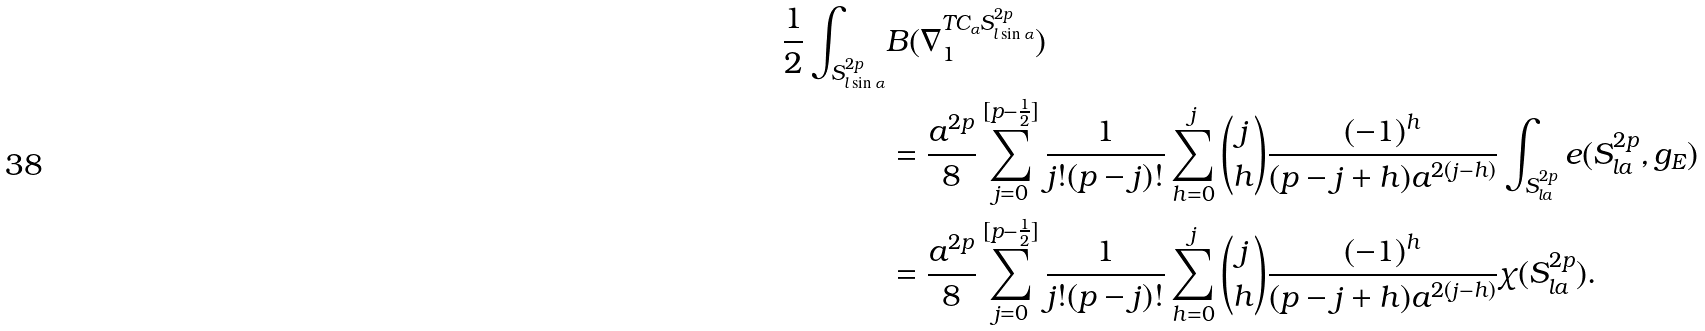Convert formula to latex. <formula><loc_0><loc_0><loc_500><loc_500>\frac { 1 } { 2 } \int _ { S ^ { 2 p } _ { l \sin \alpha } } & B ( \nabla _ { 1 } ^ { T C _ { \alpha } S ^ { 2 p } _ { l \sin \alpha } } ) \\ & = \frac { a ^ { 2 p } } { 8 } \sum _ { j = 0 } ^ { [ p - \frac { 1 } { 2 } ] } \frac { 1 } { j ! ( p - j ) ! } \sum _ { h = 0 } ^ { j } \binom { j } { h } \frac { ( - 1 ) ^ { h } } { ( p - j + h ) a ^ { 2 ( j - h ) } } \int _ { S ^ { 2 p } _ { l a } } e ( S ^ { 2 p } _ { l a } , g _ { E } ) \\ & = \frac { a ^ { 2 p } } { 8 } \sum _ { j = 0 } ^ { [ p - \frac { 1 } { 2 } ] } \frac { 1 } { j ! ( p - j ) ! } \sum _ { h = 0 } ^ { j } \binom { j } { h } \frac { ( - 1 ) ^ { h } } { ( p - j + h ) a ^ { 2 ( j - h ) } } \chi ( S ^ { 2 p } _ { l a } ) .</formula> 